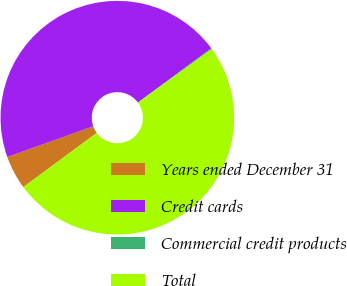<chart> <loc_0><loc_0><loc_500><loc_500><pie_chart><fcel>Years ended December 31<fcel>Credit cards<fcel>Commercial credit products<fcel>Total<nl><fcel>4.66%<fcel>45.34%<fcel>0.12%<fcel>49.88%<nl></chart> 